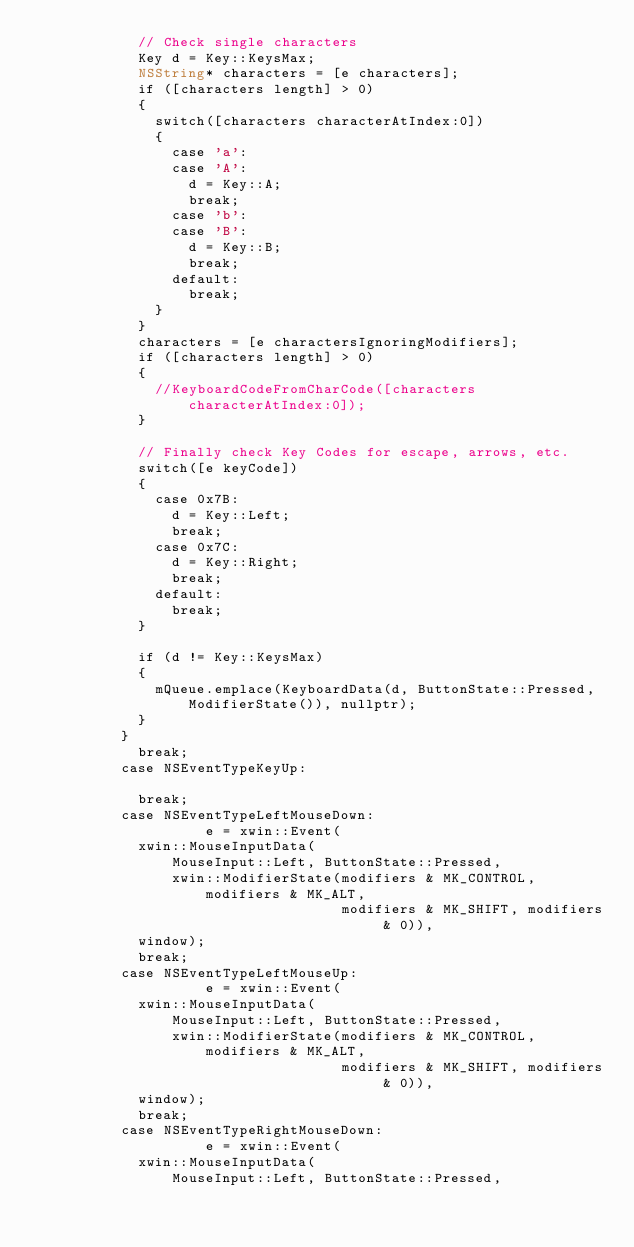Convert code to text. <code><loc_0><loc_0><loc_500><loc_500><_ObjectiveC_>            // Check single characters
						Key d = Key::KeysMax;
						NSString* characters = [e characters];
						if ([characters length] > 0)
						{
							switch([characters characterAtIndex:0])
							{
								case 'a':
								case 'A':
									d = Key::A;
									break;
								case 'b':
								case 'B':
									d = Key::B;
									break;
								default:
									break;
							}
						}
            characters = [e charactersIgnoringModifiers];
            if ([characters length] > 0)
            {
              //KeyboardCodeFromCharCode([characters characterAtIndex:0]);
            }
						
						// Finally check Key Codes for escape, arrows, etc.
						switch([e keyCode])
						{
							case 0x7B:
								d = Key::Left;
								break;
							case 0x7C:
								d = Key::Right;
								break;
							default:
								break;
						}

						if (d != Key::KeysMax)
						{
							mQueue.emplace(KeyboardData(d, ButtonState::Pressed, ModifierState()), nullptr);
						}
					}
						break;
					case NSEventTypeKeyUp:
						
						break;
					case NSEventTypeLeftMouseDown:
						        e = xwin::Event(
            xwin::MouseInputData(
                MouseInput::Left, ButtonState::Pressed,
                xwin::ModifierState(modifiers & MK_CONTROL, modifiers & MK_ALT,
                                    modifiers & MK_SHIFT, modifiers & 0)),
            window);
						break;
					case NSEventTypeLeftMouseUp:
						        e = xwin::Event(
            xwin::MouseInputData(
                MouseInput::Left, ButtonState::Pressed,
                xwin::ModifierState(modifiers & MK_CONTROL, modifiers & MK_ALT,
                                    modifiers & MK_SHIFT, modifiers & 0)),
            window);
						break;
					case NSEventTypeRightMouseDown:
						        e = xwin::Event(
            xwin::MouseInputData(
                MouseInput::Left, ButtonState::Pressed,</code> 